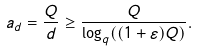<formula> <loc_0><loc_0><loc_500><loc_500>a _ { d } = \frac { Q } { d } \geq \frac { Q } { \log _ { q } ( ( 1 + \varepsilon ) Q ) } .</formula> 